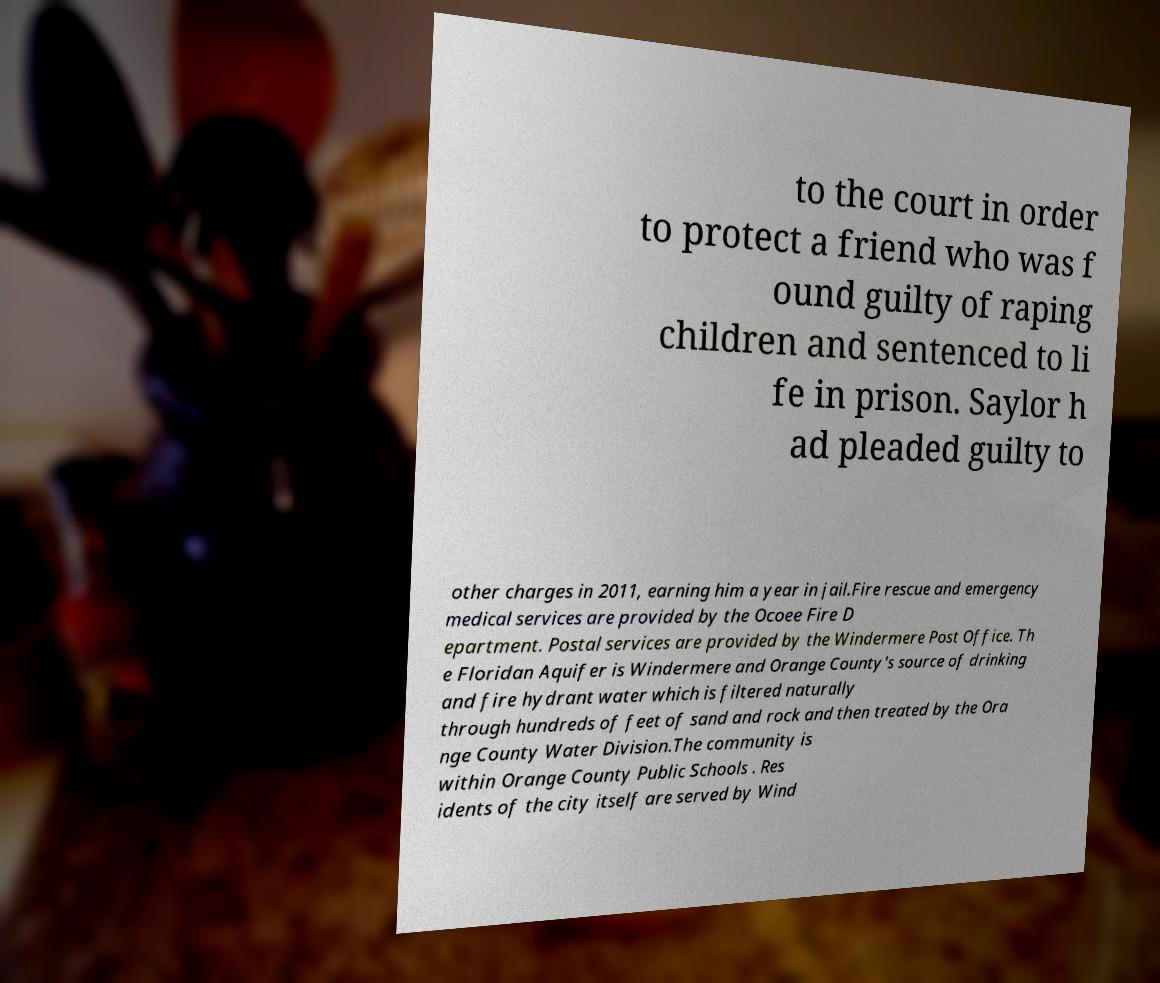Please identify and transcribe the text found in this image. to the court in order to protect a friend who was f ound guilty of raping children and sentenced to li fe in prison. Saylor h ad pleaded guilty to other charges in 2011, earning him a year in jail.Fire rescue and emergency medical services are provided by the Ocoee Fire D epartment. Postal services are provided by the Windermere Post Office. Th e Floridan Aquifer is Windermere and Orange County's source of drinking and fire hydrant water which is filtered naturally through hundreds of feet of sand and rock and then treated by the Ora nge County Water Division.The community is within Orange County Public Schools . Res idents of the city itself are served by Wind 